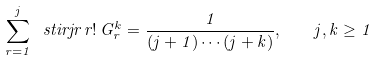<formula> <loc_0><loc_0><loc_500><loc_500>\sum _ { r = 1 } ^ { j } \ s t i r { j } { r } \, r ! \, G _ { r } ^ { k } = \frac { 1 } { ( j + 1 ) \cdots ( j + k ) } , \quad j , k \geq 1</formula> 